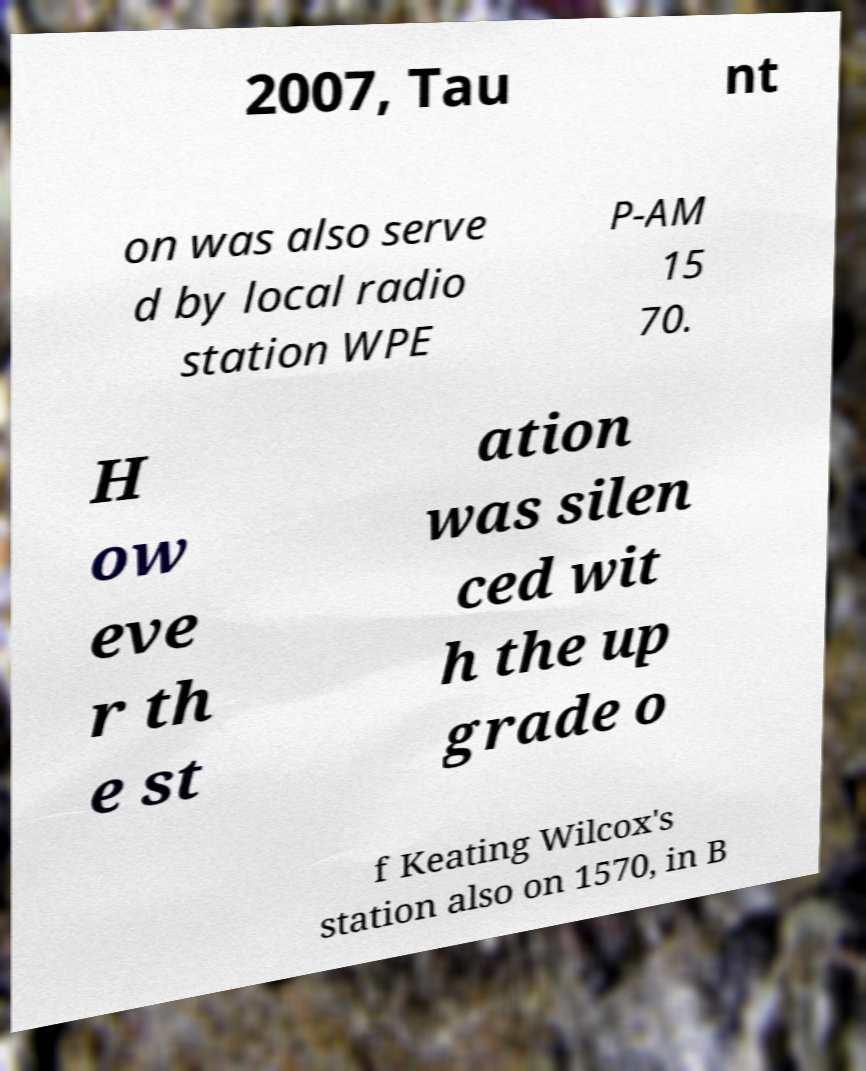Could you extract and type out the text from this image? 2007, Tau nt on was also serve d by local radio station WPE P-AM 15 70. H ow eve r th e st ation was silen ced wit h the up grade o f Keating Wilcox's station also on 1570, in B 